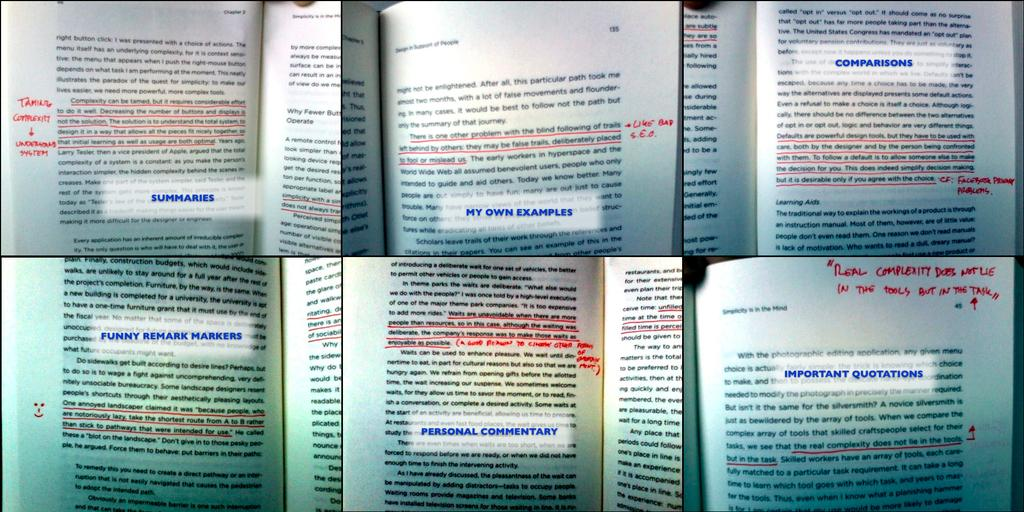<image>
Write a terse but informative summary of the picture. Book page that says "My Own Examples" in blue. 